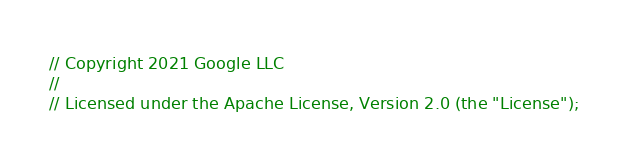Convert code to text. <code><loc_0><loc_0><loc_500><loc_500><_C_>// Copyright 2021 Google LLC
//
// Licensed under the Apache License, Version 2.0 (the "License");</code> 